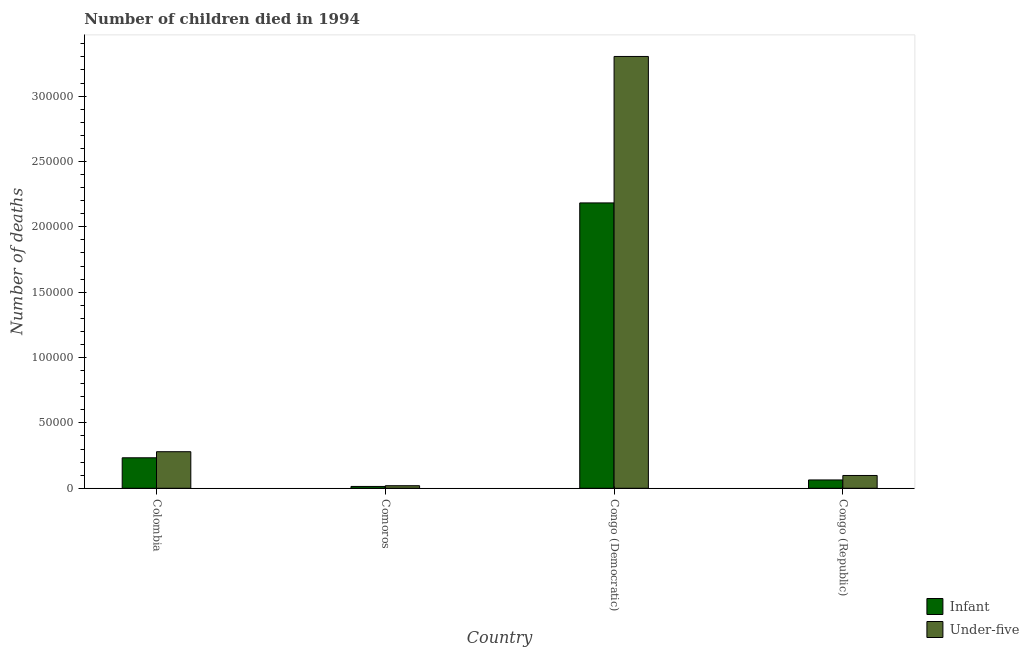How many different coloured bars are there?
Your answer should be compact. 2. How many groups of bars are there?
Your response must be concise. 4. Are the number of bars per tick equal to the number of legend labels?
Your answer should be very brief. Yes. In how many cases, is the number of bars for a given country not equal to the number of legend labels?
Give a very brief answer. 0. What is the number of infant deaths in Colombia?
Your response must be concise. 2.33e+04. Across all countries, what is the maximum number of infant deaths?
Offer a very short reply. 2.18e+05. Across all countries, what is the minimum number of under-five deaths?
Offer a terse response. 1969. In which country was the number of infant deaths maximum?
Provide a short and direct response. Congo (Democratic). In which country was the number of under-five deaths minimum?
Offer a terse response. Comoros. What is the total number of under-five deaths in the graph?
Make the answer very short. 3.70e+05. What is the difference between the number of under-five deaths in Comoros and that in Congo (Democratic)?
Offer a very short reply. -3.28e+05. What is the difference between the number of under-five deaths in Colombia and the number of infant deaths in Congo (Democratic)?
Provide a succinct answer. -1.90e+05. What is the average number of infant deaths per country?
Keep it short and to the point. 6.23e+04. What is the difference between the number of under-five deaths and number of infant deaths in Comoros?
Offer a very short reply. 566. What is the ratio of the number of under-five deaths in Congo (Democratic) to that in Congo (Republic)?
Make the answer very short. 33.72. Is the difference between the number of under-five deaths in Colombia and Congo (Republic) greater than the difference between the number of infant deaths in Colombia and Congo (Republic)?
Offer a terse response. Yes. What is the difference between the highest and the second highest number of under-five deaths?
Offer a terse response. 3.02e+05. What is the difference between the highest and the lowest number of under-five deaths?
Offer a very short reply. 3.28e+05. In how many countries, is the number of infant deaths greater than the average number of infant deaths taken over all countries?
Your response must be concise. 1. Is the sum of the number of under-five deaths in Comoros and Congo (Democratic) greater than the maximum number of infant deaths across all countries?
Offer a very short reply. Yes. What does the 2nd bar from the left in Congo (Democratic) represents?
Your answer should be compact. Under-five. What does the 1st bar from the right in Colombia represents?
Your answer should be very brief. Under-five. How many bars are there?
Provide a succinct answer. 8. How many countries are there in the graph?
Give a very brief answer. 4. Where does the legend appear in the graph?
Keep it short and to the point. Bottom right. What is the title of the graph?
Make the answer very short. Number of children died in 1994. Does "Services" appear as one of the legend labels in the graph?
Ensure brevity in your answer.  No. What is the label or title of the X-axis?
Provide a short and direct response. Country. What is the label or title of the Y-axis?
Ensure brevity in your answer.  Number of deaths. What is the Number of deaths of Infant in Colombia?
Provide a succinct answer. 2.33e+04. What is the Number of deaths of Under-five in Colombia?
Ensure brevity in your answer.  2.80e+04. What is the Number of deaths of Infant in Comoros?
Keep it short and to the point. 1403. What is the Number of deaths in Under-five in Comoros?
Keep it short and to the point. 1969. What is the Number of deaths of Infant in Congo (Democratic)?
Offer a terse response. 2.18e+05. What is the Number of deaths of Under-five in Congo (Democratic)?
Your answer should be very brief. 3.30e+05. What is the Number of deaths in Infant in Congo (Republic)?
Offer a very short reply. 6372. What is the Number of deaths in Under-five in Congo (Republic)?
Keep it short and to the point. 9796. Across all countries, what is the maximum Number of deaths of Infant?
Keep it short and to the point. 2.18e+05. Across all countries, what is the maximum Number of deaths in Under-five?
Ensure brevity in your answer.  3.30e+05. Across all countries, what is the minimum Number of deaths of Infant?
Give a very brief answer. 1403. Across all countries, what is the minimum Number of deaths of Under-five?
Keep it short and to the point. 1969. What is the total Number of deaths in Infant in the graph?
Your response must be concise. 2.49e+05. What is the total Number of deaths in Under-five in the graph?
Your answer should be very brief. 3.70e+05. What is the difference between the Number of deaths in Infant in Colombia and that in Comoros?
Offer a terse response. 2.19e+04. What is the difference between the Number of deaths in Under-five in Colombia and that in Comoros?
Make the answer very short. 2.60e+04. What is the difference between the Number of deaths of Infant in Colombia and that in Congo (Democratic)?
Give a very brief answer. -1.95e+05. What is the difference between the Number of deaths in Under-five in Colombia and that in Congo (Democratic)?
Offer a very short reply. -3.02e+05. What is the difference between the Number of deaths of Infant in Colombia and that in Congo (Republic)?
Your answer should be very brief. 1.70e+04. What is the difference between the Number of deaths in Under-five in Colombia and that in Congo (Republic)?
Your answer should be very brief. 1.82e+04. What is the difference between the Number of deaths of Infant in Comoros and that in Congo (Democratic)?
Provide a succinct answer. -2.17e+05. What is the difference between the Number of deaths in Under-five in Comoros and that in Congo (Democratic)?
Give a very brief answer. -3.28e+05. What is the difference between the Number of deaths of Infant in Comoros and that in Congo (Republic)?
Give a very brief answer. -4969. What is the difference between the Number of deaths in Under-five in Comoros and that in Congo (Republic)?
Keep it short and to the point. -7827. What is the difference between the Number of deaths of Infant in Congo (Democratic) and that in Congo (Republic)?
Your response must be concise. 2.12e+05. What is the difference between the Number of deaths of Under-five in Congo (Democratic) and that in Congo (Republic)?
Offer a very short reply. 3.21e+05. What is the difference between the Number of deaths in Infant in Colombia and the Number of deaths in Under-five in Comoros?
Offer a very short reply. 2.14e+04. What is the difference between the Number of deaths of Infant in Colombia and the Number of deaths of Under-five in Congo (Democratic)?
Ensure brevity in your answer.  -3.07e+05. What is the difference between the Number of deaths of Infant in Colombia and the Number of deaths of Under-five in Congo (Republic)?
Your answer should be compact. 1.35e+04. What is the difference between the Number of deaths in Infant in Comoros and the Number of deaths in Under-five in Congo (Democratic)?
Offer a very short reply. -3.29e+05. What is the difference between the Number of deaths of Infant in Comoros and the Number of deaths of Under-five in Congo (Republic)?
Your response must be concise. -8393. What is the difference between the Number of deaths in Infant in Congo (Democratic) and the Number of deaths in Under-five in Congo (Republic)?
Ensure brevity in your answer.  2.08e+05. What is the average Number of deaths of Infant per country?
Ensure brevity in your answer.  6.23e+04. What is the average Number of deaths of Under-five per country?
Give a very brief answer. 9.25e+04. What is the difference between the Number of deaths in Infant and Number of deaths in Under-five in Colombia?
Offer a very short reply. -4657. What is the difference between the Number of deaths of Infant and Number of deaths of Under-five in Comoros?
Ensure brevity in your answer.  -566. What is the difference between the Number of deaths of Infant and Number of deaths of Under-five in Congo (Democratic)?
Provide a short and direct response. -1.12e+05. What is the difference between the Number of deaths of Infant and Number of deaths of Under-five in Congo (Republic)?
Your answer should be very brief. -3424. What is the ratio of the Number of deaths in Infant in Colombia to that in Comoros?
Your response must be concise. 16.62. What is the ratio of the Number of deaths in Under-five in Colombia to that in Comoros?
Your answer should be compact. 14.21. What is the ratio of the Number of deaths in Infant in Colombia to that in Congo (Democratic)?
Your answer should be compact. 0.11. What is the ratio of the Number of deaths of Under-five in Colombia to that in Congo (Democratic)?
Provide a succinct answer. 0.08. What is the ratio of the Number of deaths in Infant in Colombia to that in Congo (Republic)?
Provide a succinct answer. 3.66. What is the ratio of the Number of deaths in Under-five in Colombia to that in Congo (Republic)?
Ensure brevity in your answer.  2.86. What is the ratio of the Number of deaths in Infant in Comoros to that in Congo (Democratic)?
Your answer should be compact. 0.01. What is the ratio of the Number of deaths of Under-five in Comoros to that in Congo (Democratic)?
Keep it short and to the point. 0.01. What is the ratio of the Number of deaths of Infant in Comoros to that in Congo (Republic)?
Offer a terse response. 0.22. What is the ratio of the Number of deaths in Under-five in Comoros to that in Congo (Republic)?
Give a very brief answer. 0.2. What is the ratio of the Number of deaths of Infant in Congo (Democratic) to that in Congo (Republic)?
Keep it short and to the point. 34.26. What is the ratio of the Number of deaths in Under-five in Congo (Democratic) to that in Congo (Republic)?
Your answer should be very brief. 33.72. What is the difference between the highest and the second highest Number of deaths of Infant?
Give a very brief answer. 1.95e+05. What is the difference between the highest and the second highest Number of deaths in Under-five?
Provide a short and direct response. 3.02e+05. What is the difference between the highest and the lowest Number of deaths of Infant?
Offer a terse response. 2.17e+05. What is the difference between the highest and the lowest Number of deaths of Under-five?
Offer a very short reply. 3.28e+05. 